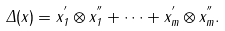Convert formula to latex. <formula><loc_0><loc_0><loc_500><loc_500>\Delta ( x ) = x _ { 1 } ^ { ^ { \prime } } \otimes x _ { 1 } ^ { ^ { \prime \prime } } + \cdots + x _ { m } ^ { ^ { \prime } } \otimes x _ { m } ^ { ^ { \prime \prime } } .</formula> 